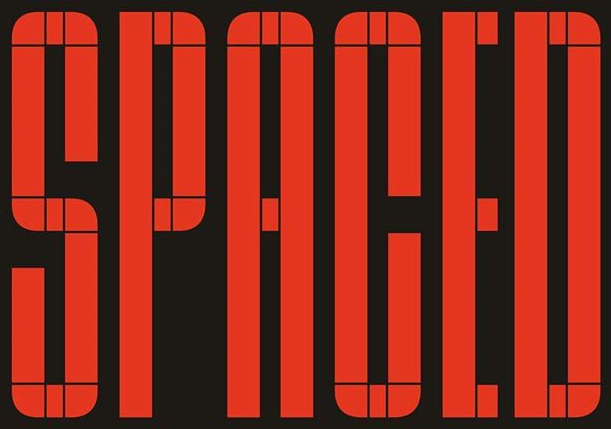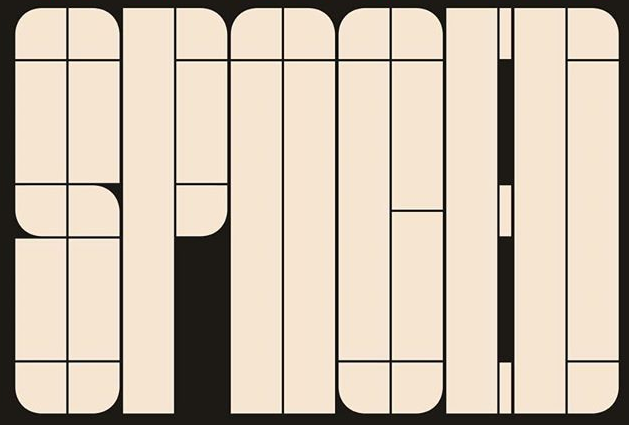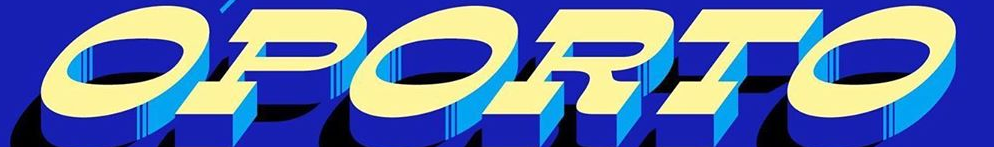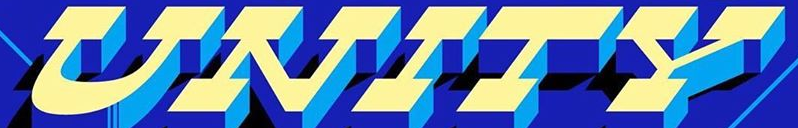What words are shown in these images in order, separated by a semicolon? SPACED; SPNOED; OPORTO; UNITY 